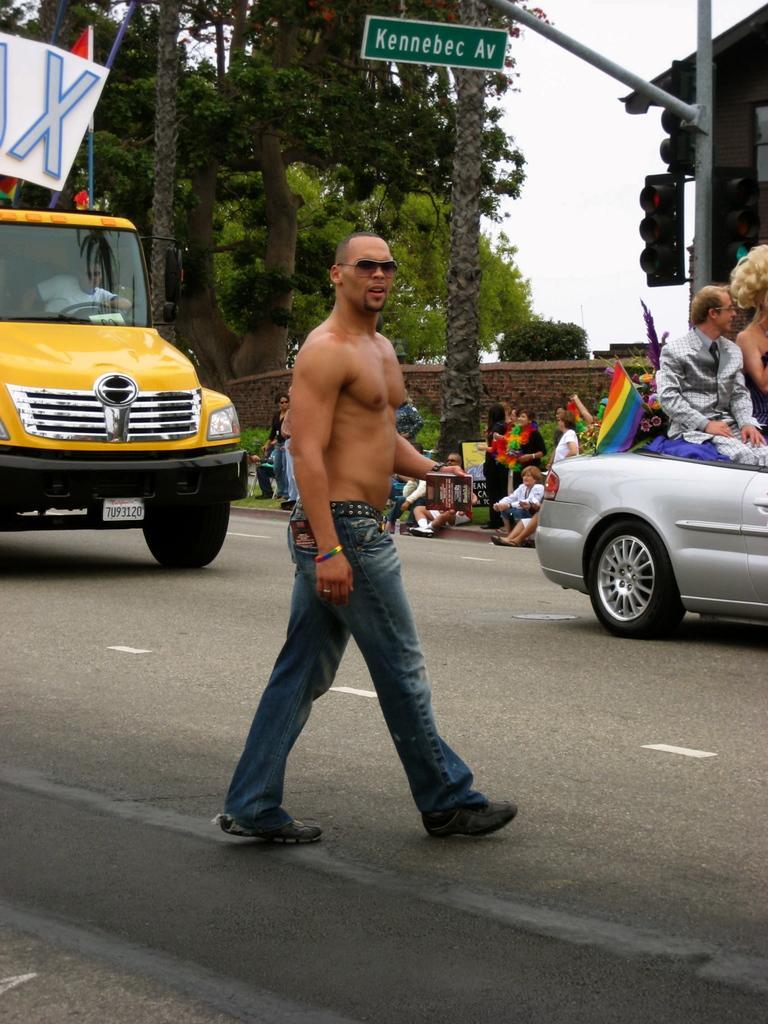Can you describe this image briefly? In this picture we can see a man walking on the road. There are some vehicles on the road. On the background we can see some trees. And this is the sky. And this is traffic signal. Even we can see some persons are sitting on the chairs. 